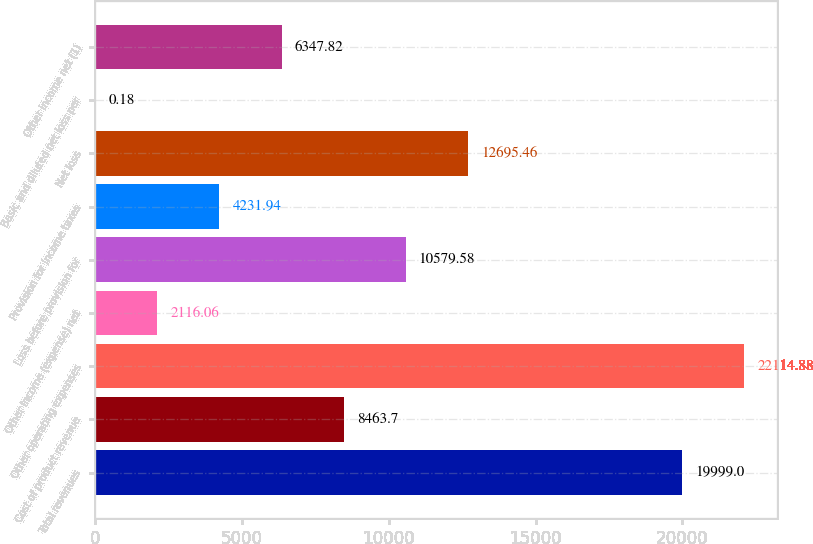Convert chart to OTSL. <chart><loc_0><loc_0><loc_500><loc_500><bar_chart><fcel>Total revenues<fcel>Cost of product revenue<fcel>Other operating expenses<fcel>Other income (expense) net<fcel>Loss before provision for<fcel>Provision for income taxes<fcel>Net loss<fcel>Basic and diluted net loss per<fcel>Other income net (1)<nl><fcel>19999<fcel>8463.7<fcel>22114.9<fcel>2116.06<fcel>10579.6<fcel>4231.94<fcel>12695.5<fcel>0.18<fcel>6347.82<nl></chart> 